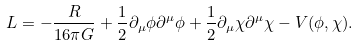<formula> <loc_0><loc_0><loc_500><loc_500>L = - \frac { R } { 1 6 \pi G } + \frac { 1 } { 2 } \partial _ { \mu } \phi \partial ^ { \mu } \phi + \frac { 1 } { 2 } \partial _ { \mu } \chi \partial ^ { \mu } \chi - V ( \phi , \chi ) .</formula> 